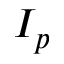Convert formula to latex. <formula><loc_0><loc_0><loc_500><loc_500>I _ { p }</formula> 